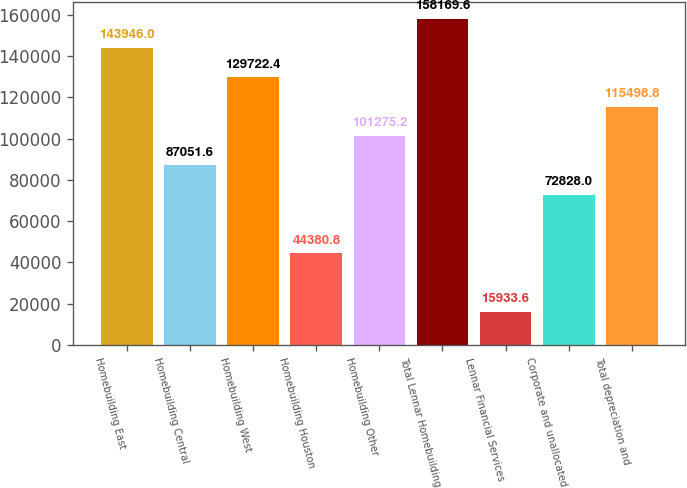Convert chart to OTSL. <chart><loc_0><loc_0><loc_500><loc_500><bar_chart><fcel>Homebuilding East<fcel>Homebuilding Central<fcel>Homebuilding West<fcel>Homebuilding Houston<fcel>Homebuilding Other<fcel>Total Lennar Homebuilding<fcel>Lennar Financial Services<fcel>Corporate and unallocated<fcel>Total depreciation and<nl><fcel>143946<fcel>87051.6<fcel>129722<fcel>44380.8<fcel>101275<fcel>158170<fcel>15933.6<fcel>72828<fcel>115499<nl></chart> 